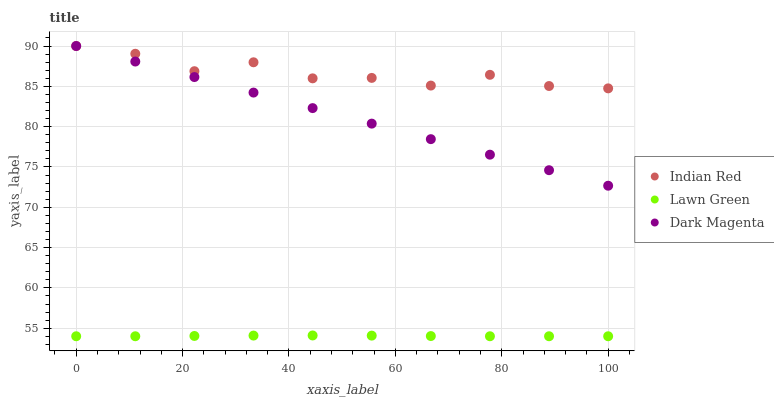Does Lawn Green have the minimum area under the curve?
Answer yes or no. Yes. Does Indian Red have the maximum area under the curve?
Answer yes or no. Yes. Does Dark Magenta have the minimum area under the curve?
Answer yes or no. No. Does Dark Magenta have the maximum area under the curve?
Answer yes or no. No. Is Dark Magenta the smoothest?
Answer yes or no. Yes. Is Indian Red the roughest?
Answer yes or no. Yes. Is Indian Red the smoothest?
Answer yes or no. No. Is Dark Magenta the roughest?
Answer yes or no. No. Does Lawn Green have the lowest value?
Answer yes or no. Yes. Does Dark Magenta have the lowest value?
Answer yes or no. No. Does Indian Red have the highest value?
Answer yes or no. Yes. Is Lawn Green less than Dark Magenta?
Answer yes or no. Yes. Is Indian Red greater than Lawn Green?
Answer yes or no. Yes. Does Indian Red intersect Dark Magenta?
Answer yes or no. Yes. Is Indian Red less than Dark Magenta?
Answer yes or no. No. Is Indian Red greater than Dark Magenta?
Answer yes or no. No. Does Lawn Green intersect Dark Magenta?
Answer yes or no. No. 